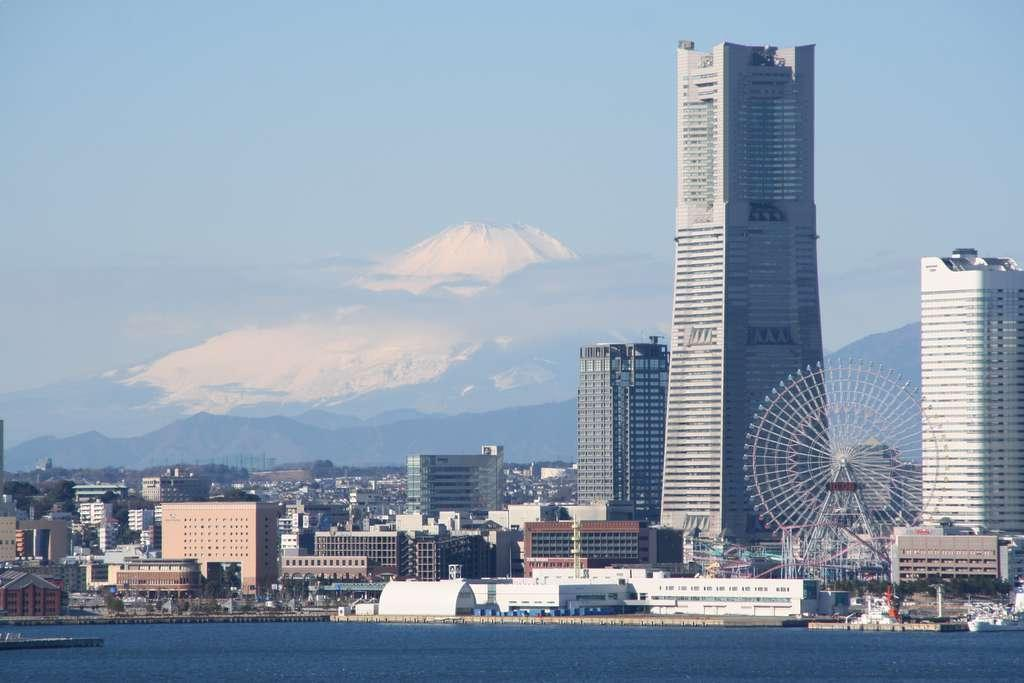What type of natural feature is present in the image? There is a river in the image. What type of man-made structures can be seen in the image? There are buildings in the image. What can be seen in the distance in the image? There are mountains in the background of the image. What is visible in the sky in the image? The sky is visible in the background of the image. Where is the goat standing in the image? There is no goat present in the image. What type of dirt can be seen on the riverbank in the image? There is no dirt visible in the image; it is a river, buildings, mountains, and sky. 